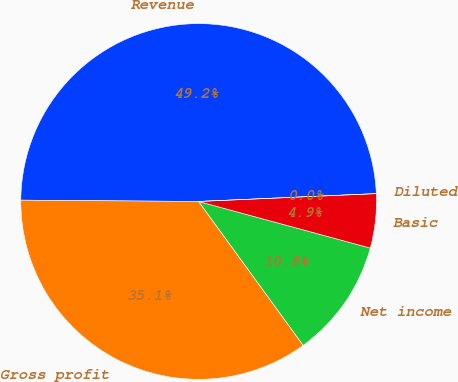<chart> <loc_0><loc_0><loc_500><loc_500><pie_chart><fcel>Revenue<fcel>Gross profit<fcel>Net income<fcel>Basic<fcel>Diluted<nl><fcel>49.18%<fcel>35.12%<fcel>10.78%<fcel>4.92%<fcel>0.0%<nl></chart> 